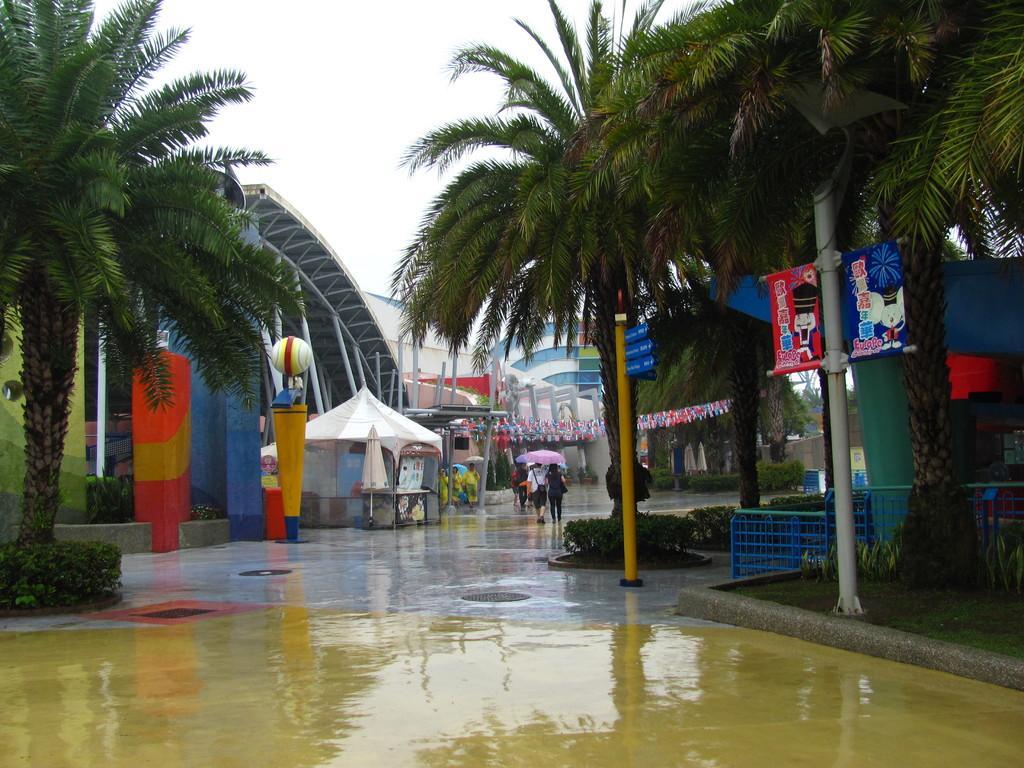Can you describe this image briefly? In this image we can see trees, plants, poles, banners on the poles, fences, few persons, an umbrella, buildings, tent, metal objects and sky. 